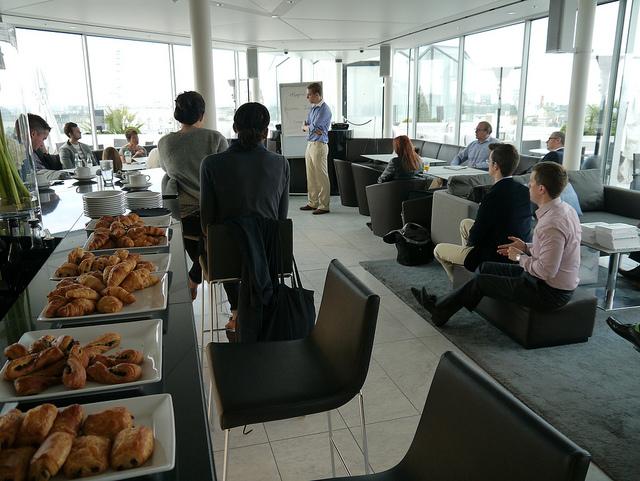Is the chef in the picture?
Answer briefly. No. Do you see vegetables?
Answer briefly. No. Must the attendees pay for the food before eating it?
Give a very brief answer. No. What food is closest to the camera?
Write a very short answer. Pastry. What is taking place in the building?
Short answer required. Meeting. 